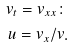<formula> <loc_0><loc_0><loc_500><loc_500>v _ { t } = v _ { x x } \colon \\ u = v _ { x } / v .</formula> 